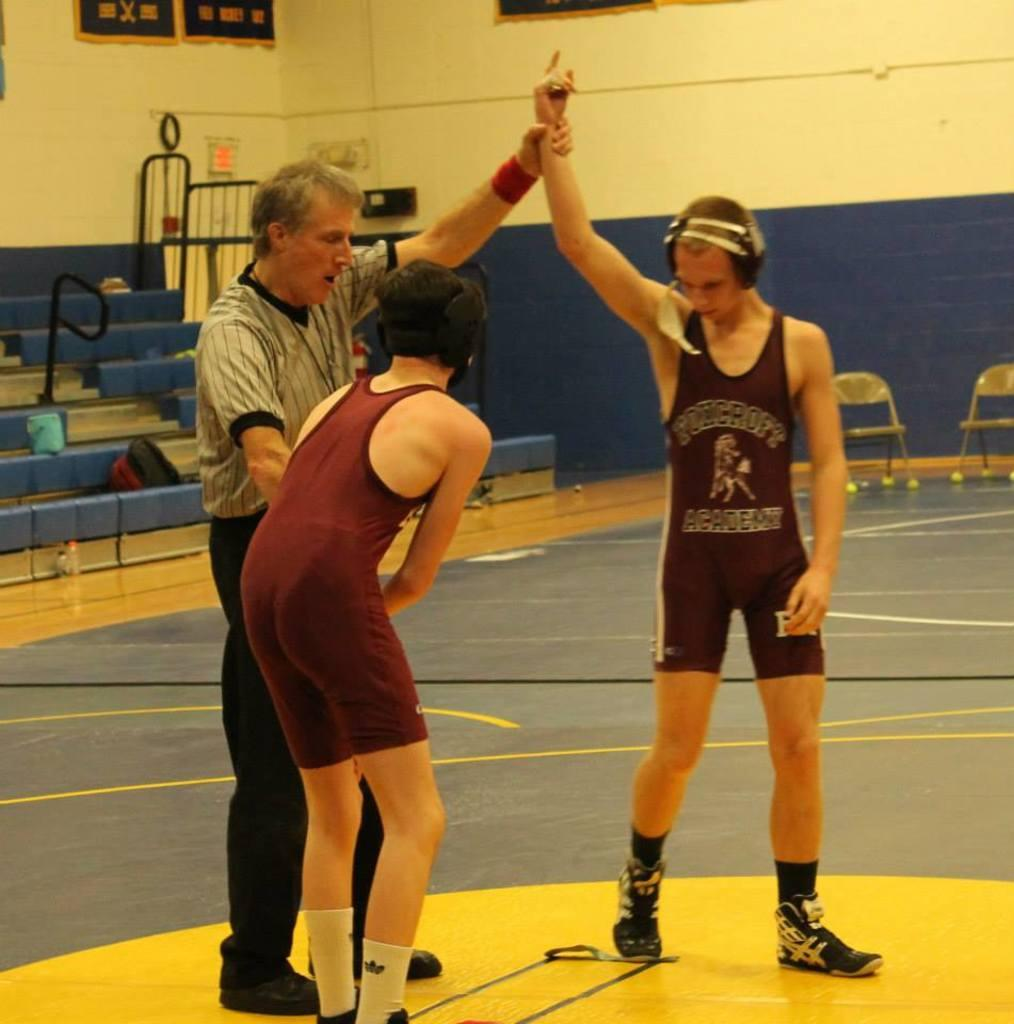<image>
Provide a brief description of the given image. The referee raises the hand of the Foncroft Academy wrestler. 